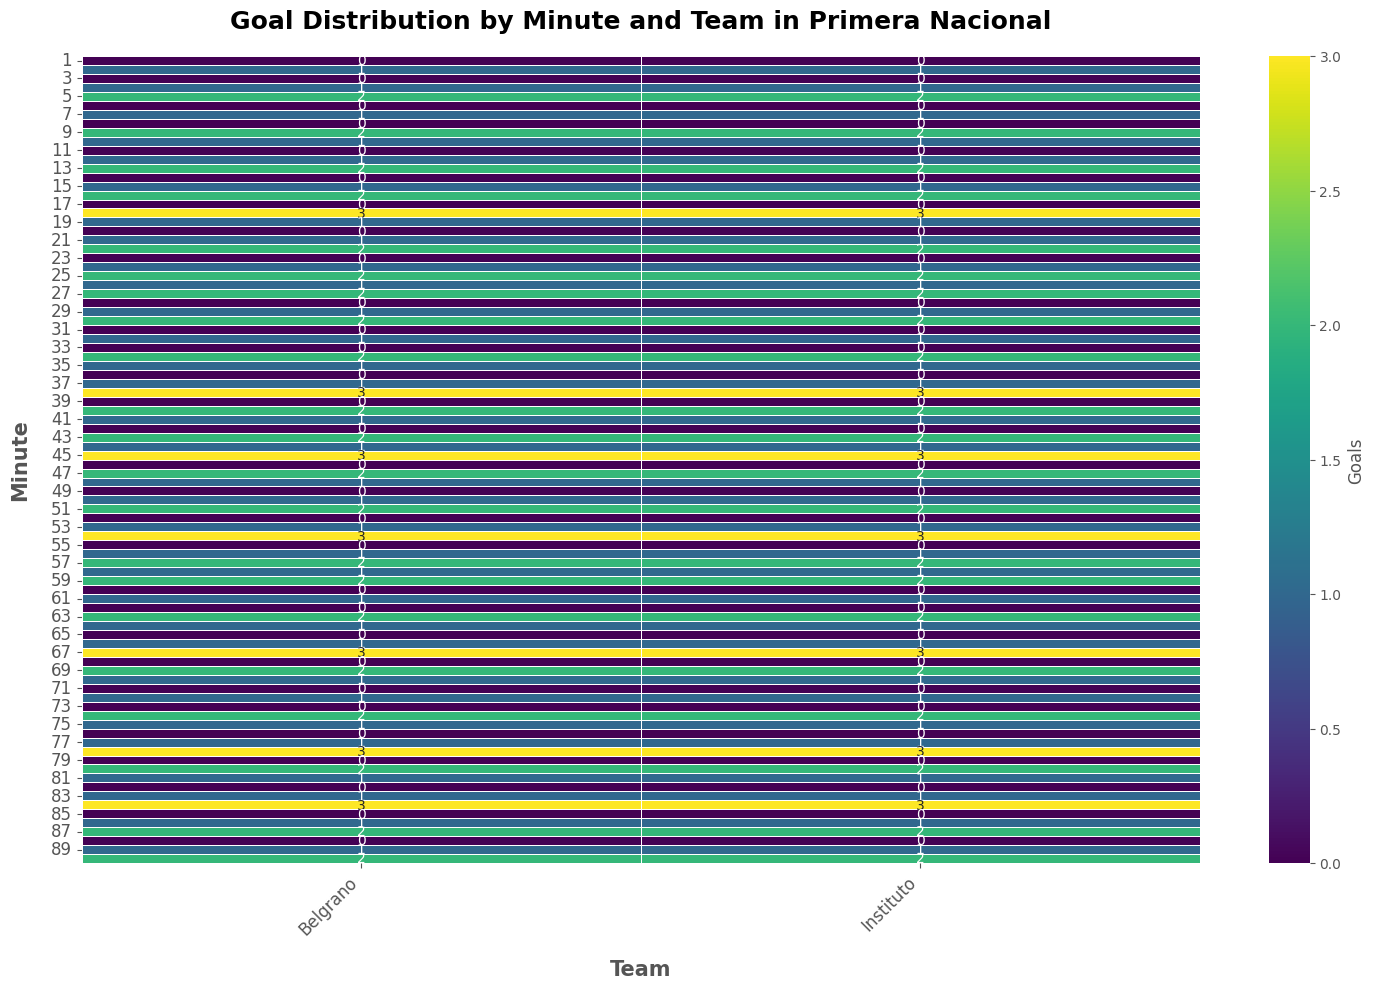Which team scored more goals in minute 18? By looking at the value at minute 18 for both Belgrano and Instituto columns in the heatmap, we can compare their goals. Belgrano scored 3 goals and Instituto also scored 3 goals in minute 18, so they are equal.
Answer: Both Which team scored the highest number of goals overall from minutes 1 to 90? To determine this, summarize the goals scored by both teams across all minutes and compare. Both teams have the same goal pattern with exact scores minute-by-minute, so their totals will be equal.
Answer: Both At which minute does Belgrano score the first 2 goals? By examining the heatmap data for Belgrano, we can see that Belgrano scored 2 goals in minute 5.
Answer: 5 On average, which team scores more goals in the first half (minutes 1-45)? Sum the goals for each team from minutes 1 to 45 and divide by the number of minutes. Since the patterns are identical for both teams, their averages will also be the same.
Answer: Both Do Belgrano and Instituto have the same goal distribution each minute? By visually inspecting the values in the heatmap for each minute for both teams, we can see that the values are identical for each corresponding minute.
Answer: Yes Which minute shows the highest goal count for Belgrano? Identify the highest value in the Belgrano column. The maximum value is 3, which occurs at minutes 18, 38, 45, 54, 67, 78, and 84.
Answer: 18, 38, 45, 54, 67, 78, 84 Compared to minute 10, does Instituto score more or fewer goals in minute 20? Instituto scored 1 goal at minute 10 and 0 goals at minute 20. Hence, Instituto scores fewer goals at minute 20 compared to minute 10.
Answer: Fewer Which minutes have no goals scored by either team? Looking at the heatmap, find minutes where both Belgrano and Instituto have a goal count of 0. The minutes where no goals were scored by either team are minutes 1, 3, 6, 8, 11, 14, 17, 20, 23, 28, 31, 33, 36, 39, 42, 46, 49, 52, 55, 60, 62, 65, 68, 71, 73, 76, 79, 82, 85, 88.
Answer: 1, 3, 6, 8, 11, 14, 17, 20, 23, 28, 31, 33, 36, 39, 42, 46, 49, 52, 55, 60, 62, 65, 68, 71, 73, 76, 79, 82, 85, 88 